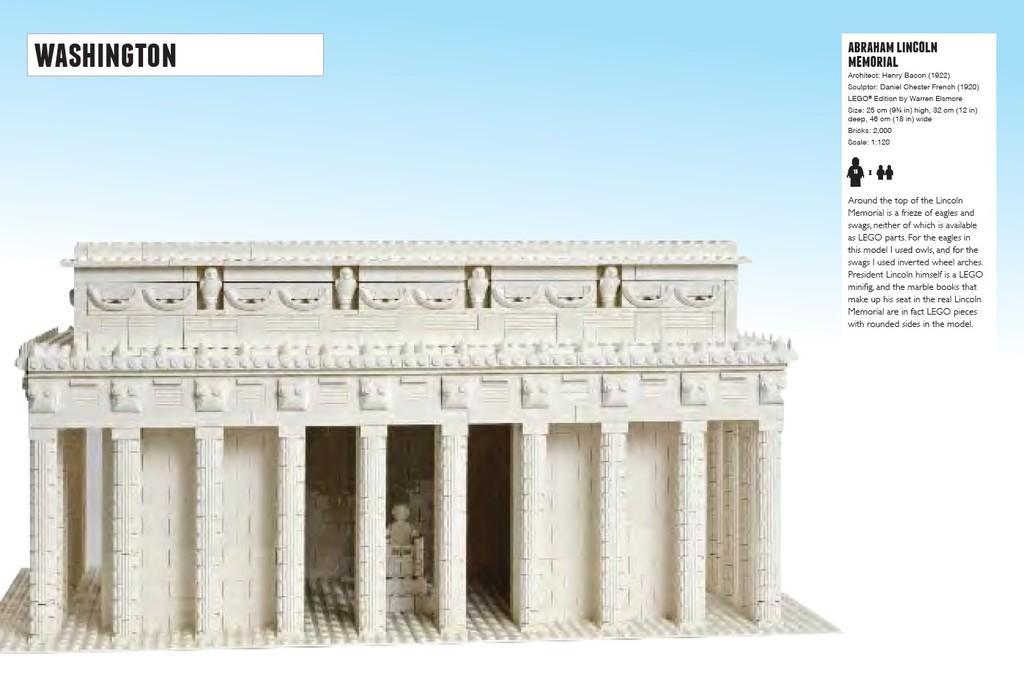Can you describe this image briefly? In this image there is a poster. There is an image of a building having few sculptures on it. Right side there is some text. Left top there is some text. 